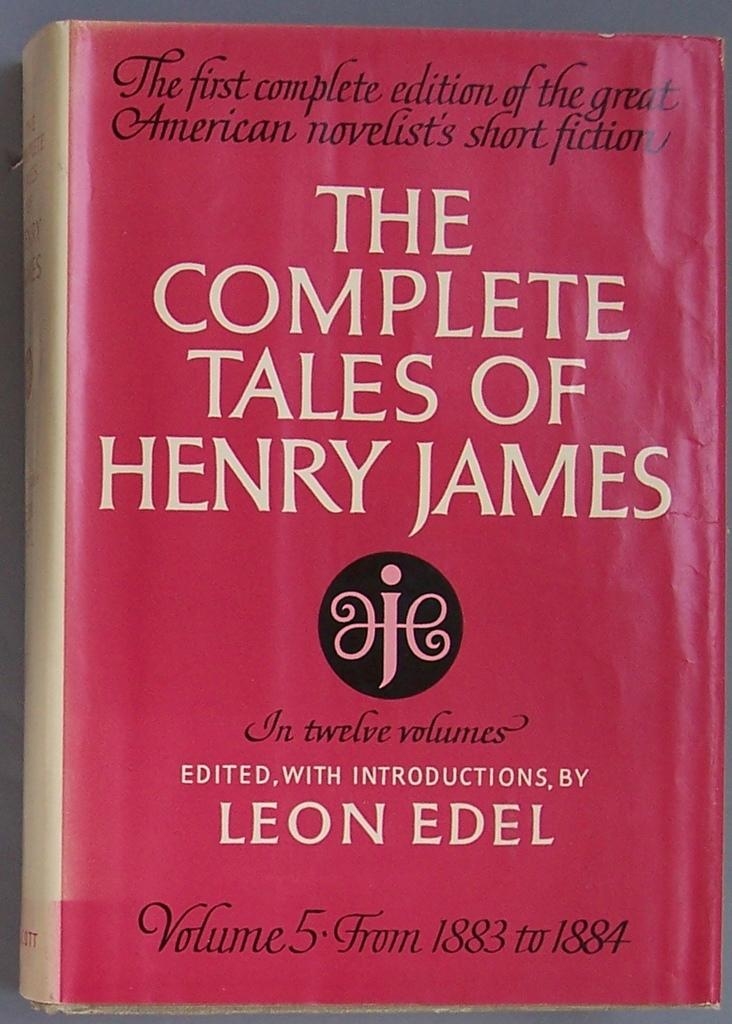<image>
Share a concise interpretation of the image provided. a close up of book The Complete Tales of Henry James 